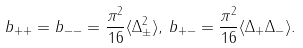Convert formula to latex. <formula><loc_0><loc_0><loc_500><loc_500>b _ { + + } = b _ { - - } = \frac { \pi ^ { 2 } } { 1 6 } \langle \Delta ^ { 2 } _ { \pm } \rangle , \, b _ { + - } = \frac { \pi ^ { 2 } } { 1 6 } \langle \Delta _ { + } \Delta _ { - } \rangle .</formula> 